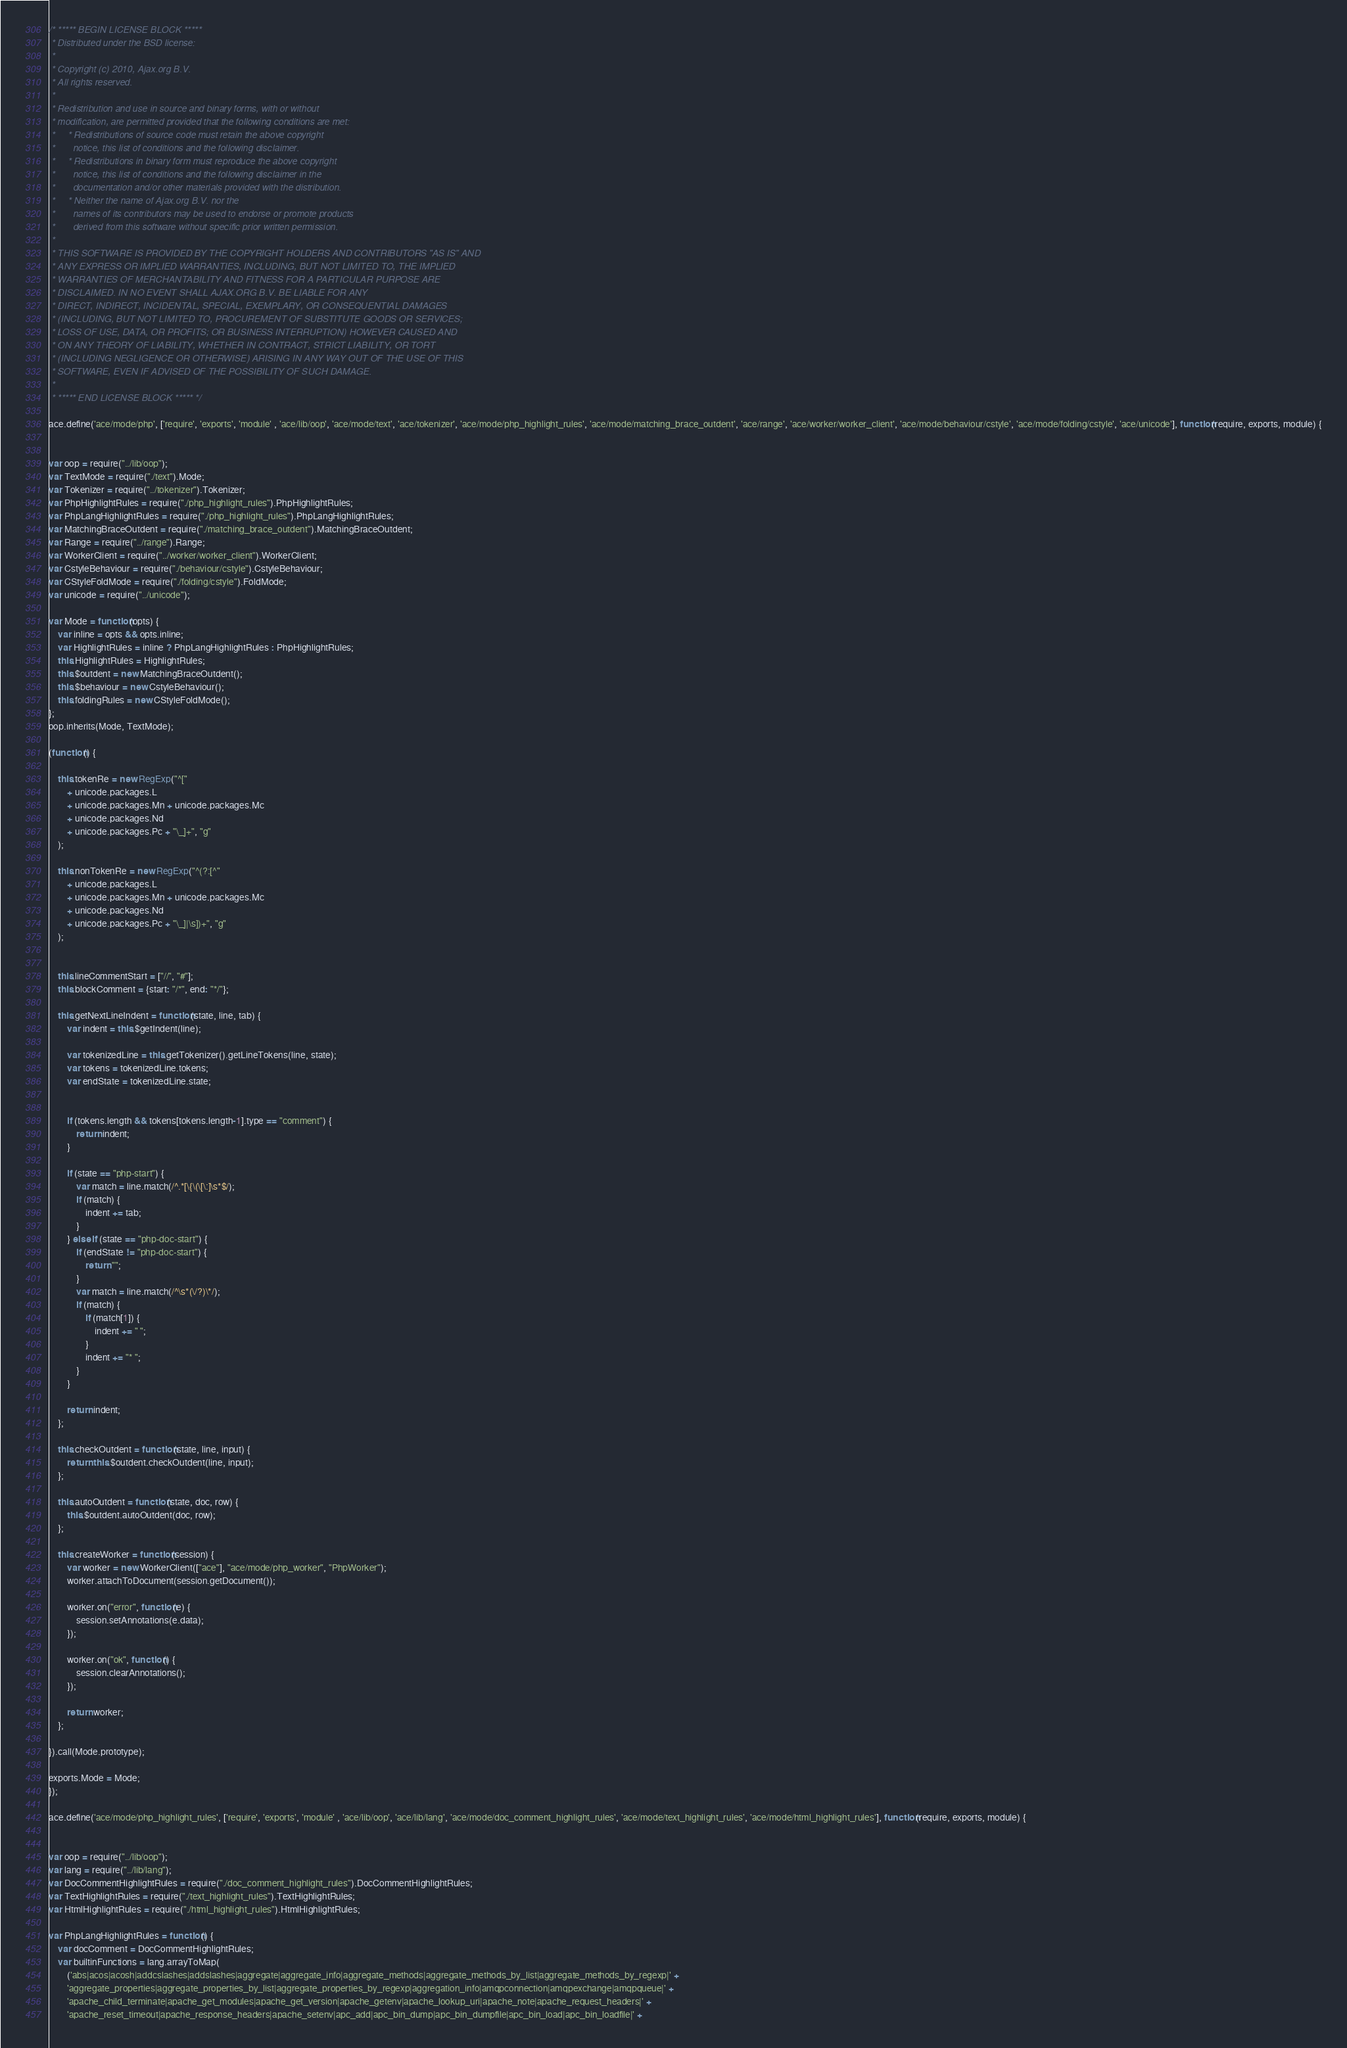<code> <loc_0><loc_0><loc_500><loc_500><_JavaScript_>/* ***** BEGIN LICENSE BLOCK *****
 * Distributed under the BSD license:
 *
 * Copyright (c) 2010, Ajax.org B.V.
 * All rights reserved.
 * 
 * Redistribution and use in source and binary forms, with or without
 * modification, are permitted provided that the following conditions are met:
 *     * Redistributions of source code must retain the above copyright
 *       notice, this list of conditions and the following disclaimer.
 *     * Redistributions in binary form must reproduce the above copyright
 *       notice, this list of conditions and the following disclaimer in the
 *       documentation and/or other materials provided with the distribution.
 *     * Neither the name of Ajax.org B.V. nor the
 *       names of its contributors may be used to endorse or promote products
 *       derived from this software without specific prior written permission.
 * 
 * THIS SOFTWARE IS PROVIDED BY THE COPYRIGHT HOLDERS AND CONTRIBUTORS "AS IS" AND
 * ANY EXPRESS OR IMPLIED WARRANTIES, INCLUDING, BUT NOT LIMITED TO, THE IMPLIED
 * WARRANTIES OF MERCHANTABILITY AND FITNESS FOR A PARTICULAR PURPOSE ARE
 * DISCLAIMED. IN NO EVENT SHALL AJAX.ORG B.V. BE LIABLE FOR ANY
 * DIRECT, INDIRECT, INCIDENTAL, SPECIAL, EXEMPLARY, OR CONSEQUENTIAL DAMAGES
 * (INCLUDING, BUT NOT LIMITED TO, PROCUREMENT OF SUBSTITUTE GOODS OR SERVICES;
 * LOSS OF USE, DATA, OR PROFITS; OR BUSINESS INTERRUPTION) HOWEVER CAUSED AND
 * ON ANY THEORY OF LIABILITY, WHETHER IN CONTRACT, STRICT LIABILITY, OR TORT
 * (INCLUDING NEGLIGENCE OR OTHERWISE) ARISING IN ANY WAY OUT OF THE USE OF THIS
 * SOFTWARE, EVEN IF ADVISED OF THE POSSIBILITY OF SUCH DAMAGE.
 *
 * ***** END LICENSE BLOCK ***** */

ace.define('ace/mode/php', ['require', 'exports', 'module' , 'ace/lib/oop', 'ace/mode/text', 'ace/tokenizer', 'ace/mode/php_highlight_rules', 'ace/mode/matching_brace_outdent', 'ace/range', 'ace/worker/worker_client', 'ace/mode/behaviour/cstyle', 'ace/mode/folding/cstyle', 'ace/unicode'], function(require, exports, module) {


var oop = require("../lib/oop");
var TextMode = require("./text").Mode;
var Tokenizer = require("../tokenizer").Tokenizer;
var PhpHighlightRules = require("./php_highlight_rules").PhpHighlightRules;
var PhpLangHighlightRules = require("./php_highlight_rules").PhpLangHighlightRules;
var MatchingBraceOutdent = require("./matching_brace_outdent").MatchingBraceOutdent;
var Range = require("../range").Range;
var WorkerClient = require("../worker/worker_client").WorkerClient;
var CstyleBehaviour = require("./behaviour/cstyle").CstyleBehaviour;
var CStyleFoldMode = require("./folding/cstyle").FoldMode;
var unicode = require("../unicode");

var Mode = function(opts) {
    var inline = opts && opts.inline;
    var HighlightRules = inline ? PhpLangHighlightRules : PhpHighlightRules;
    this.HighlightRules = HighlightRules;
    this.$outdent = new MatchingBraceOutdent();
    this.$behaviour = new CstyleBehaviour();
    this.foldingRules = new CStyleFoldMode();
};
oop.inherits(Mode, TextMode);

(function() {

    this.tokenRe = new RegExp("^["
        + unicode.packages.L
        + unicode.packages.Mn + unicode.packages.Mc
        + unicode.packages.Nd
        + unicode.packages.Pc + "\_]+", "g"
    );
    
    this.nonTokenRe = new RegExp("^(?:[^"
        + unicode.packages.L
        + unicode.packages.Mn + unicode.packages.Mc
        + unicode.packages.Nd
        + unicode.packages.Pc + "\_]|\s])+", "g"
    );

       
    this.lineCommentStart = ["//", "#"];
    this.blockComment = {start: "/*", end: "*/"};

    this.getNextLineIndent = function(state, line, tab) {
        var indent = this.$getIndent(line);

        var tokenizedLine = this.getTokenizer().getLineTokens(line, state);
        var tokens = tokenizedLine.tokens;
        var endState = tokenizedLine.state;


        if (tokens.length && tokens[tokens.length-1].type == "comment") {
            return indent;
        }

        if (state == "php-start") {
            var match = line.match(/^.*[\{\(\[\:]\s*$/);
            if (match) {
                indent += tab;
            }
        } else if (state == "php-doc-start") {
            if (endState != "php-doc-start") {
                return "";
            }
            var match = line.match(/^\s*(\/?)\*/);
            if (match) {
                if (match[1]) {
                    indent += " ";
                }
                indent += "* ";
            }
        }

        return indent;
    };

    this.checkOutdent = function(state, line, input) {
        return this.$outdent.checkOutdent(line, input);
    };

    this.autoOutdent = function(state, doc, row) {
        this.$outdent.autoOutdent(doc, row);
    };

    this.createWorker = function(session) {
        var worker = new WorkerClient(["ace"], "ace/mode/php_worker", "PhpWorker");
        worker.attachToDocument(session.getDocument());

        worker.on("error", function(e) {
            session.setAnnotations(e.data);
        });

        worker.on("ok", function() {
            session.clearAnnotations();
        });

        return worker;
    };

}).call(Mode.prototype);

exports.Mode = Mode;
});

ace.define('ace/mode/php_highlight_rules', ['require', 'exports', 'module' , 'ace/lib/oop', 'ace/lib/lang', 'ace/mode/doc_comment_highlight_rules', 'ace/mode/text_highlight_rules', 'ace/mode/html_highlight_rules'], function(require, exports, module) {


var oop = require("../lib/oop");
var lang = require("../lib/lang");
var DocCommentHighlightRules = require("./doc_comment_highlight_rules").DocCommentHighlightRules;
var TextHighlightRules = require("./text_highlight_rules").TextHighlightRules;
var HtmlHighlightRules = require("./html_highlight_rules").HtmlHighlightRules;

var PhpLangHighlightRules = function() {
    var docComment = DocCommentHighlightRules;
    var builtinFunctions = lang.arrayToMap(
        ('abs|acos|acosh|addcslashes|addslashes|aggregate|aggregate_info|aggregate_methods|aggregate_methods_by_list|aggregate_methods_by_regexp|' +
        'aggregate_properties|aggregate_properties_by_list|aggregate_properties_by_regexp|aggregation_info|amqpconnection|amqpexchange|amqpqueue|' +
        'apache_child_terminate|apache_get_modules|apache_get_version|apache_getenv|apache_lookup_uri|apache_note|apache_request_headers|' +
        'apache_reset_timeout|apache_response_headers|apache_setenv|apc_add|apc_bin_dump|apc_bin_dumpfile|apc_bin_load|apc_bin_loadfile|' +</code> 